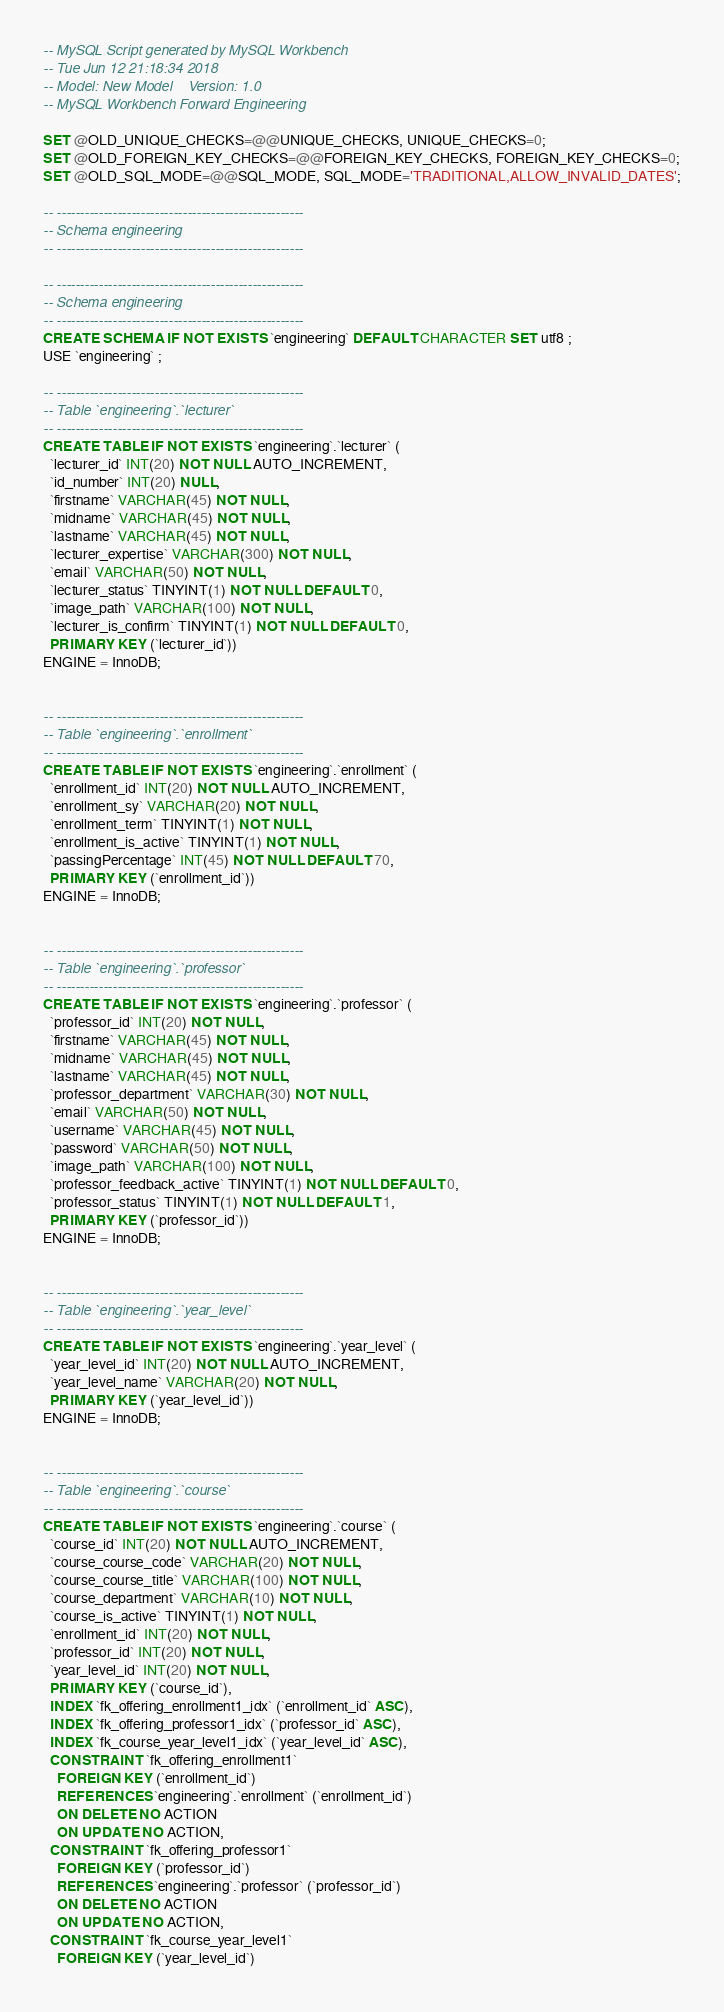Convert code to text. <code><loc_0><loc_0><loc_500><loc_500><_SQL_>-- MySQL Script generated by MySQL Workbench
-- Tue Jun 12 21:18:34 2018
-- Model: New Model    Version: 1.0
-- MySQL Workbench Forward Engineering

SET @OLD_UNIQUE_CHECKS=@@UNIQUE_CHECKS, UNIQUE_CHECKS=0;
SET @OLD_FOREIGN_KEY_CHECKS=@@FOREIGN_KEY_CHECKS, FOREIGN_KEY_CHECKS=0;
SET @OLD_SQL_MODE=@@SQL_MODE, SQL_MODE='TRADITIONAL,ALLOW_INVALID_DATES';

-- -----------------------------------------------------
-- Schema engineering
-- -----------------------------------------------------

-- -----------------------------------------------------
-- Schema engineering
-- -----------------------------------------------------
CREATE SCHEMA IF NOT EXISTS `engineering` DEFAULT CHARACTER SET utf8 ;
USE `engineering` ;

-- -----------------------------------------------------
-- Table `engineering`.`lecturer`
-- -----------------------------------------------------
CREATE TABLE IF NOT EXISTS `engineering`.`lecturer` (
  `lecturer_id` INT(20) NOT NULL AUTO_INCREMENT,
  `id_number` INT(20) NULL,
  `firstname` VARCHAR(45) NOT NULL,
  `midname` VARCHAR(45) NOT NULL,
  `lastname` VARCHAR(45) NOT NULL,
  `lecturer_expertise` VARCHAR(300) NOT NULL,
  `email` VARCHAR(50) NOT NULL,
  `lecturer_status` TINYINT(1) NOT NULL DEFAULT 0,
  `image_path` VARCHAR(100) NOT NULL,
  `lecturer_is_confirm` TINYINT(1) NOT NULL DEFAULT 0,
  PRIMARY KEY (`lecturer_id`))
ENGINE = InnoDB;


-- -----------------------------------------------------
-- Table `engineering`.`enrollment`
-- -----------------------------------------------------
CREATE TABLE IF NOT EXISTS `engineering`.`enrollment` (
  `enrollment_id` INT(20) NOT NULL AUTO_INCREMENT,
  `enrollment_sy` VARCHAR(20) NOT NULL,
  `enrollment_term` TINYINT(1) NOT NULL,
  `enrollment_is_active` TINYINT(1) NOT NULL,
  `passingPercentage` INT(45) NOT NULL DEFAULT 70,
  PRIMARY KEY (`enrollment_id`))
ENGINE = InnoDB;


-- -----------------------------------------------------
-- Table `engineering`.`professor`
-- -----------------------------------------------------
CREATE TABLE IF NOT EXISTS `engineering`.`professor` (
  `professor_id` INT(20) NOT NULL,
  `firstname` VARCHAR(45) NOT NULL,
  `midname` VARCHAR(45) NOT NULL,
  `lastname` VARCHAR(45) NOT NULL,
  `professor_department` VARCHAR(30) NOT NULL,
  `email` VARCHAR(50) NOT NULL,
  `username` VARCHAR(45) NOT NULL,
  `password` VARCHAR(50) NOT NULL,
  `image_path` VARCHAR(100) NOT NULL,
  `professor_feedback_active` TINYINT(1) NOT NULL DEFAULT 0,
  `professor_status` TINYINT(1) NOT NULL DEFAULT 1,
  PRIMARY KEY (`professor_id`))
ENGINE = InnoDB;


-- -----------------------------------------------------
-- Table `engineering`.`year_level`
-- -----------------------------------------------------
CREATE TABLE IF NOT EXISTS `engineering`.`year_level` (
  `year_level_id` INT(20) NOT NULL AUTO_INCREMENT,
  `year_level_name` VARCHAR(20) NOT NULL,
  PRIMARY KEY (`year_level_id`))
ENGINE = InnoDB;


-- -----------------------------------------------------
-- Table `engineering`.`course`
-- -----------------------------------------------------
CREATE TABLE IF NOT EXISTS `engineering`.`course` (
  `course_id` INT(20) NOT NULL AUTO_INCREMENT,
  `course_course_code` VARCHAR(20) NOT NULL,
  `course_course_title` VARCHAR(100) NOT NULL,
  `course_department` VARCHAR(10) NOT NULL,
  `course_is_active` TINYINT(1) NOT NULL,
  `enrollment_id` INT(20) NOT NULL,
  `professor_id` INT(20) NOT NULL,
  `year_level_id` INT(20) NOT NULL,
  PRIMARY KEY (`course_id`),
  INDEX `fk_offering_enrollment1_idx` (`enrollment_id` ASC),
  INDEX `fk_offering_professor1_idx` (`professor_id` ASC),
  INDEX `fk_course_year_level1_idx` (`year_level_id` ASC),
  CONSTRAINT `fk_offering_enrollment1`
    FOREIGN KEY (`enrollment_id`)
    REFERENCES `engineering`.`enrollment` (`enrollment_id`)
    ON DELETE NO ACTION
    ON UPDATE NO ACTION,
  CONSTRAINT `fk_offering_professor1`
    FOREIGN KEY (`professor_id`)
    REFERENCES `engineering`.`professor` (`professor_id`)
    ON DELETE NO ACTION
    ON UPDATE NO ACTION,
  CONSTRAINT `fk_course_year_level1`
    FOREIGN KEY (`year_level_id`)</code> 